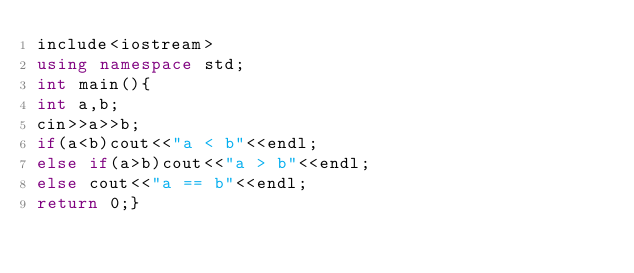<code> <loc_0><loc_0><loc_500><loc_500><_C++_>include<iostream>
using namespace std;
int main(){
int a,b;
cin>>a>>b;
if(a<b)cout<<"a < b"<<endl;
else if(a>b)cout<<"a > b"<<endl;
else cout<<"a == b"<<endl;
return 0;}
</code> 